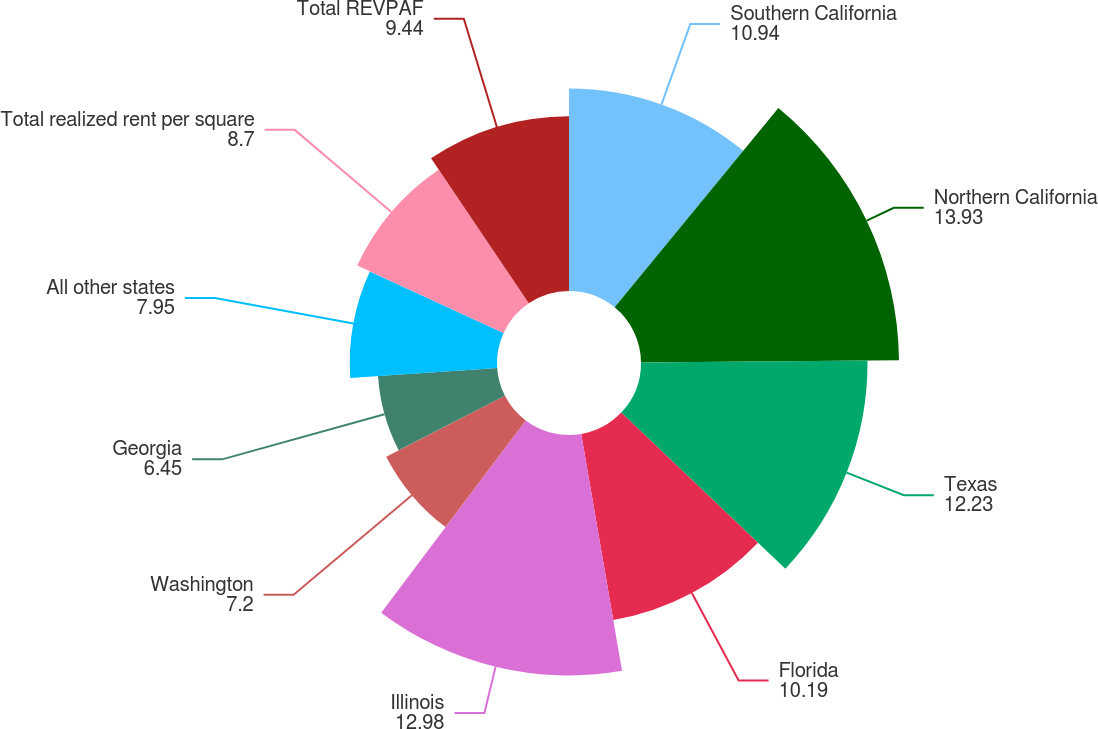Convert chart. <chart><loc_0><loc_0><loc_500><loc_500><pie_chart><fcel>Southern California<fcel>Northern California<fcel>Texas<fcel>Florida<fcel>Illinois<fcel>Washington<fcel>Georgia<fcel>All other states<fcel>Total realized rent per square<fcel>Total REVPAF<nl><fcel>10.94%<fcel>13.93%<fcel>12.23%<fcel>10.19%<fcel>12.98%<fcel>7.2%<fcel>6.45%<fcel>7.95%<fcel>8.7%<fcel>9.44%<nl></chart> 